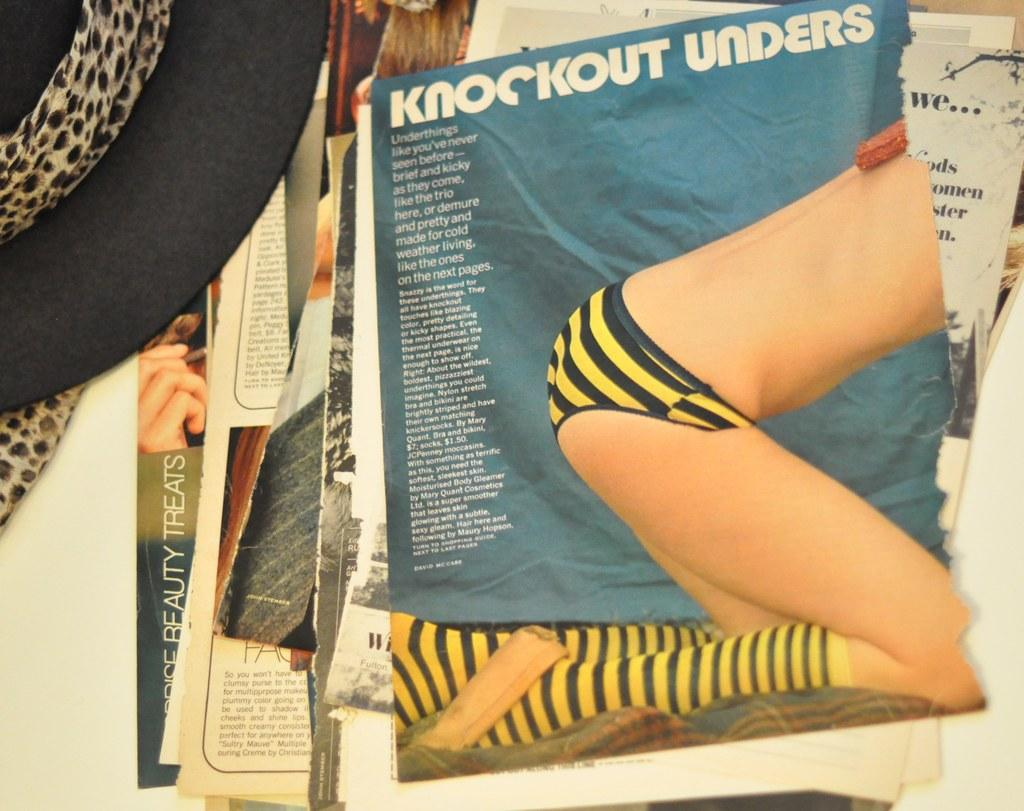<image>
Create a compact narrative representing the image presented. A magazine titled "Knockout Unders" that is on a pile. 